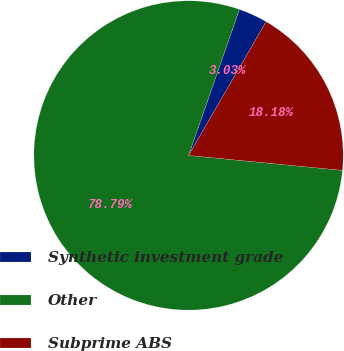Convert chart. <chart><loc_0><loc_0><loc_500><loc_500><pie_chart><fcel>Synthetic investment grade<fcel>Other<fcel>Subprime ABS<nl><fcel>3.03%<fcel>78.79%<fcel>18.18%<nl></chart> 